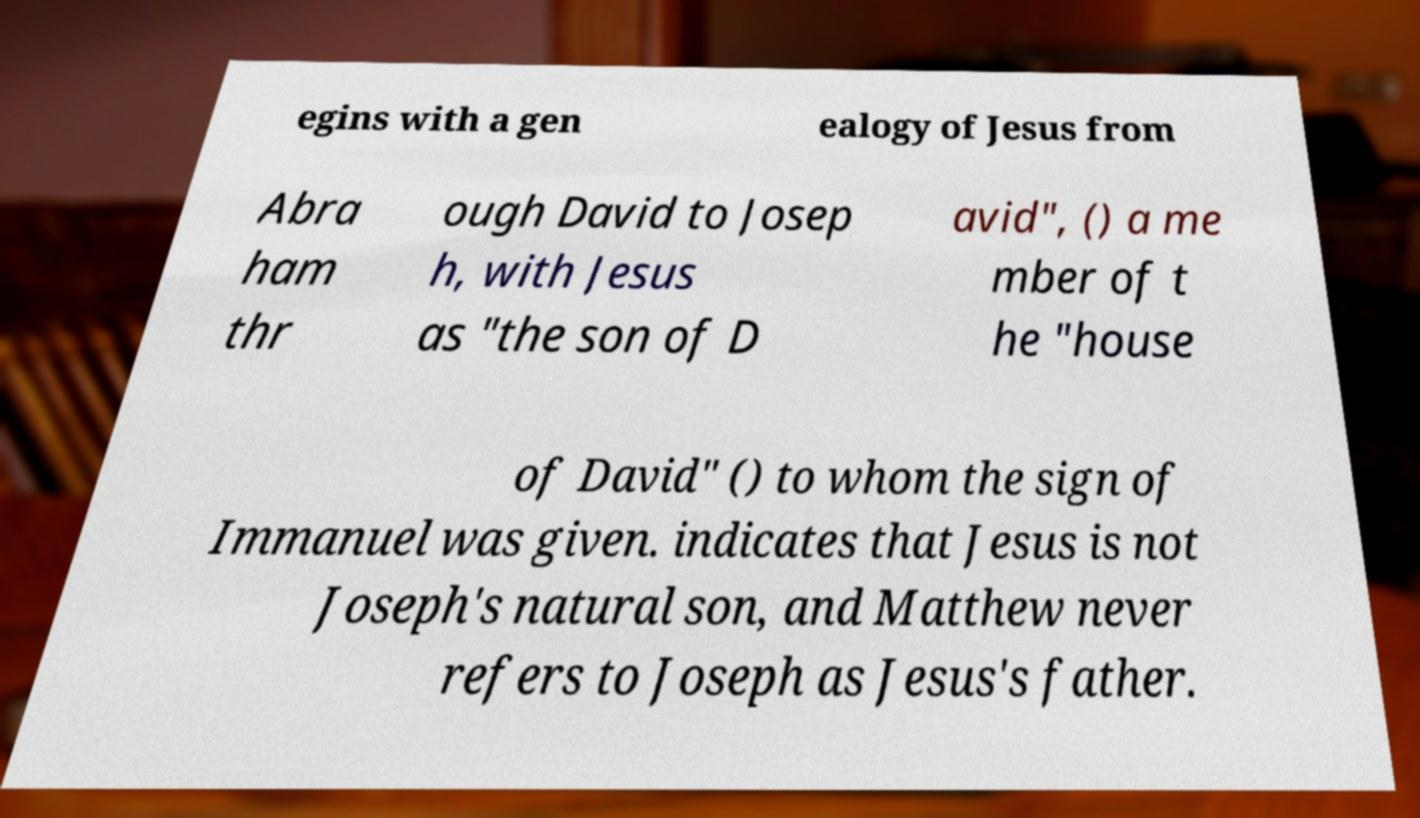Please read and relay the text visible in this image. What does it say? egins with a gen ealogy of Jesus from Abra ham thr ough David to Josep h, with Jesus as "the son of D avid", () a me mber of t he "house of David" () to whom the sign of Immanuel was given. indicates that Jesus is not Joseph's natural son, and Matthew never refers to Joseph as Jesus's father. 